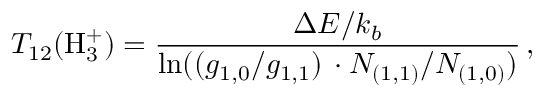<formula> <loc_0><loc_0><loc_500><loc_500>T _ { 1 2 } ( H _ { 3 } ^ { + } ) = \frac { \Delta E / k _ { b } } { \ln ( ( g _ { 1 , 0 } / g _ { 1 , 1 } ) \, \cdot N _ { ( 1 , 1 ) } / N _ { ( 1 , 0 ) } ) } \, ,</formula> 